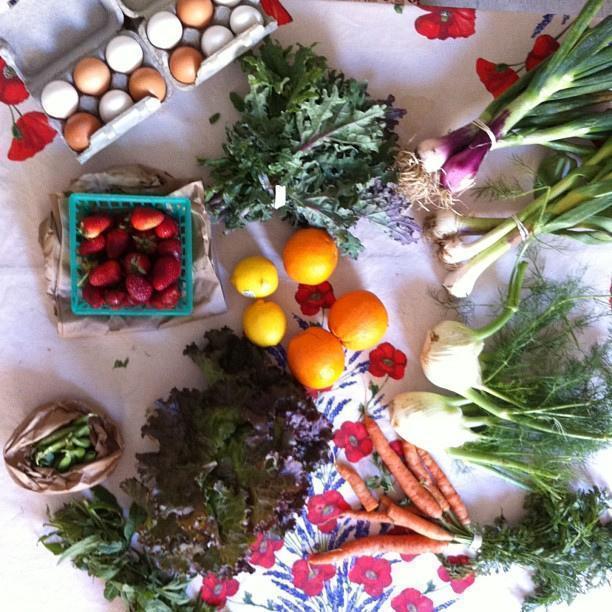What is the orange item near the bottom of the pile?
From the following four choices, select the correct answer to address the question.
Options: Garfield doll, lime, carrot, thumb tack. Carrot. 